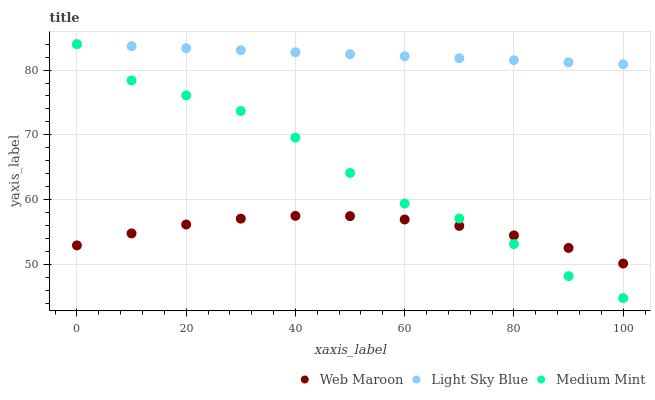Does Web Maroon have the minimum area under the curve?
Answer yes or no. Yes. Does Light Sky Blue have the maximum area under the curve?
Answer yes or no. Yes. Does Light Sky Blue have the minimum area under the curve?
Answer yes or no. No. Does Web Maroon have the maximum area under the curve?
Answer yes or no. No. Is Light Sky Blue the smoothest?
Answer yes or no. Yes. Is Medium Mint the roughest?
Answer yes or no. Yes. Is Web Maroon the smoothest?
Answer yes or no. No. Is Web Maroon the roughest?
Answer yes or no. No. Does Medium Mint have the lowest value?
Answer yes or no. Yes. Does Web Maroon have the lowest value?
Answer yes or no. No. Does Light Sky Blue have the highest value?
Answer yes or no. Yes. Does Web Maroon have the highest value?
Answer yes or no. No. Is Web Maroon less than Light Sky Blue?
Answer yes or no. Yes. Is Light Sky Blue greater than Web Maroon?
Answer yes or no. Yes. Does Medium Mint intersect Web Maroon?
Answer yes or no. Yes. Is Medium Mint less than Web Maroon?
Answer yes or no. No. Is Medium Mint greater than Web Maroon?
Answer yes or no. No. Does Web Maroon intersect Light Sky Blue?
Answer yes or no. No. 